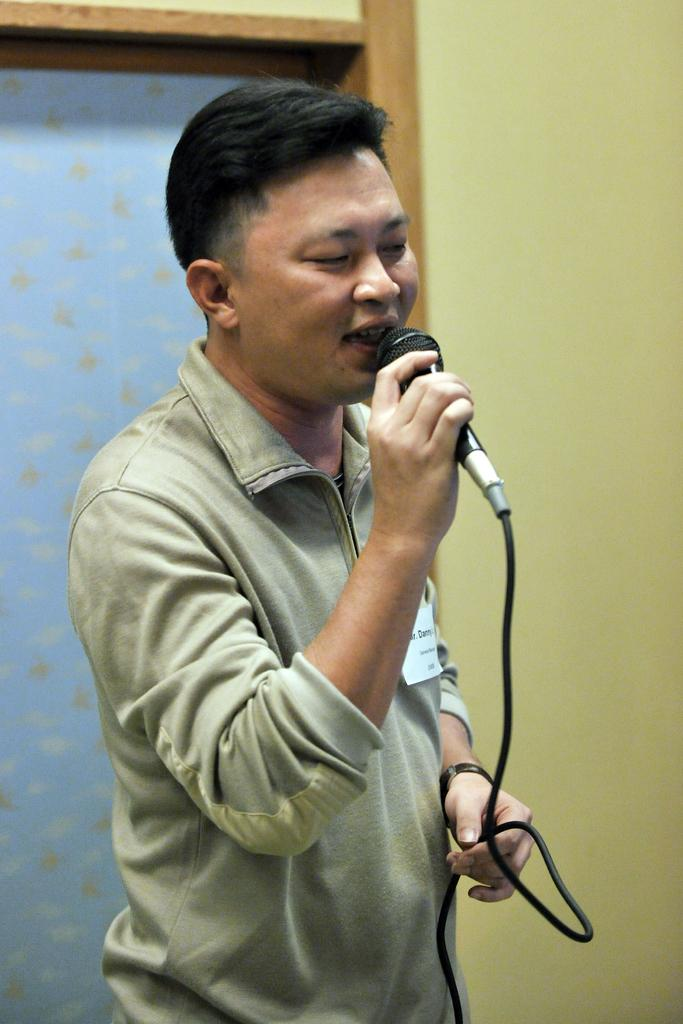What is the person in the image doing? The person is holding a microphone in their hand. What objects can be seen in the image besides the person? There is a door and a wall in the image. Can you describe the setting of the image? The image may have been taken in a hall. What type of fork is the person using to teach in the image? There is no fork present in the image, and the person is not teaching. 